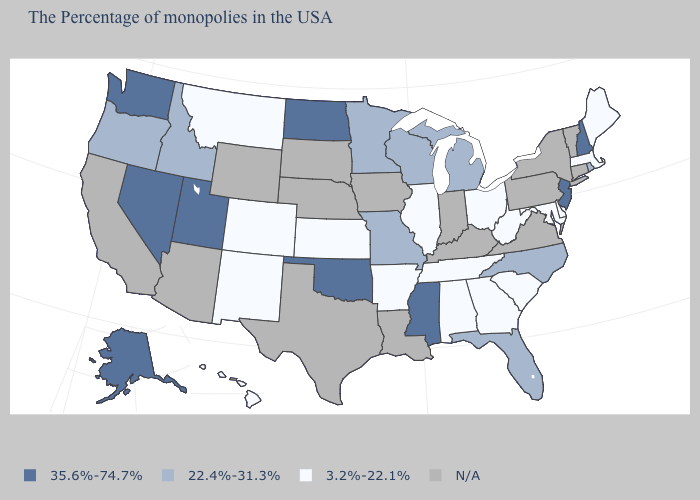What is the value of Connecticut?
Concise answer only. N/A. Which states have the lowest value in the MidWest?
Quick response, please. Ohio, Illinois, Kansas. What is the value of Virginia?
Be succinct. N/A. Which states have the lowest value in the MidWest?
Concise answer only. Ohio, Illinois, Kansas. Does the first symbol in the legend represent the smallest category?
Give a very brief answer. No. Is the legend a continuous bar?
Answer briefly. No. What is the lowest value in states that border Vermont?
Write a very short answer. 3.2%-22.1%. Name the states that have a value in the range 3.2%-22.1%?
Write a very short answer. Maine, Massachusetts, Delaware, Maryland, South Carolina, West Virginia, Ohio, Georgia, Alabama, Tennessee, Illinois, Arkansas, Kansas, Colorado, New Mexico, Montana, Hawaii. Name the states that have a value in the range 3.2%-22.1%?
Short answer required. Maine, Massachusetts, Delaware, Maryland, South Carolina, West Virginia, Ohio, Georgia, Alabama, Tennessee, Illinois, Arkansas, Kansas, Colorado, New Mexico, Montana, Hawaii. Which states have the lowest value in the USA?
Quick response, please. Maine, Massachusetts, Delaware, Maryland, South Carolina, West Virginia, Ohio, Georgia, Alabama, Tennessee, Illinois, Arkansas, Kansas, Colorado, New Mexico, Montana, Hawaii. Among the states that border California , which have the highest value?
Answer briefly. Nevada. What is the value of Missouri?
Short answer required. 22.4%-31.3%. Is the legend a continuous bar?
Concise answer only. No. What is the highest value in the USA?
Give a very brief answer. 35.6%-74.7%. Name the states that have a value in the range 35.6%-74.7%?
Give a very brief answer. New Hampshire, New Jersey, Mississippi, Oklahoma, North Dakota, Utah, Nevada, Washington, Alaska. 